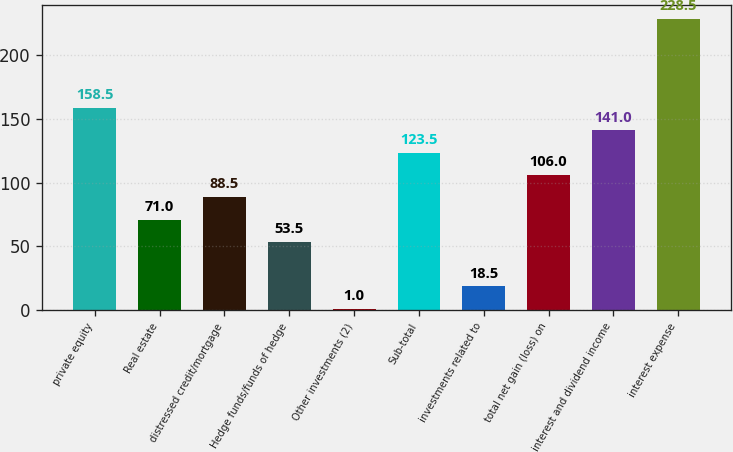Convert chart to OTSL. <chart><loc_0><loc_0><loc_500><loc_500><bar_chart><fcel>private equity<fcel>Real estate<fcel>distressed credit/mortgage<fcel>Hedge funds/funds of hedge<fcel>Other investments (2)<fcel>Sub-total<fcel>investments related to<fcel>total net gain (loss) on<fcel>interest and dividend income<fcel>interest expense<nl><fcel>158.5<fcel>71<fcel>88.5<fcel>53.5<fcel>1<fcel>123.5<fcel>18.5<fcel>106<fcel>141<fcel>228.5<nl></chart> 